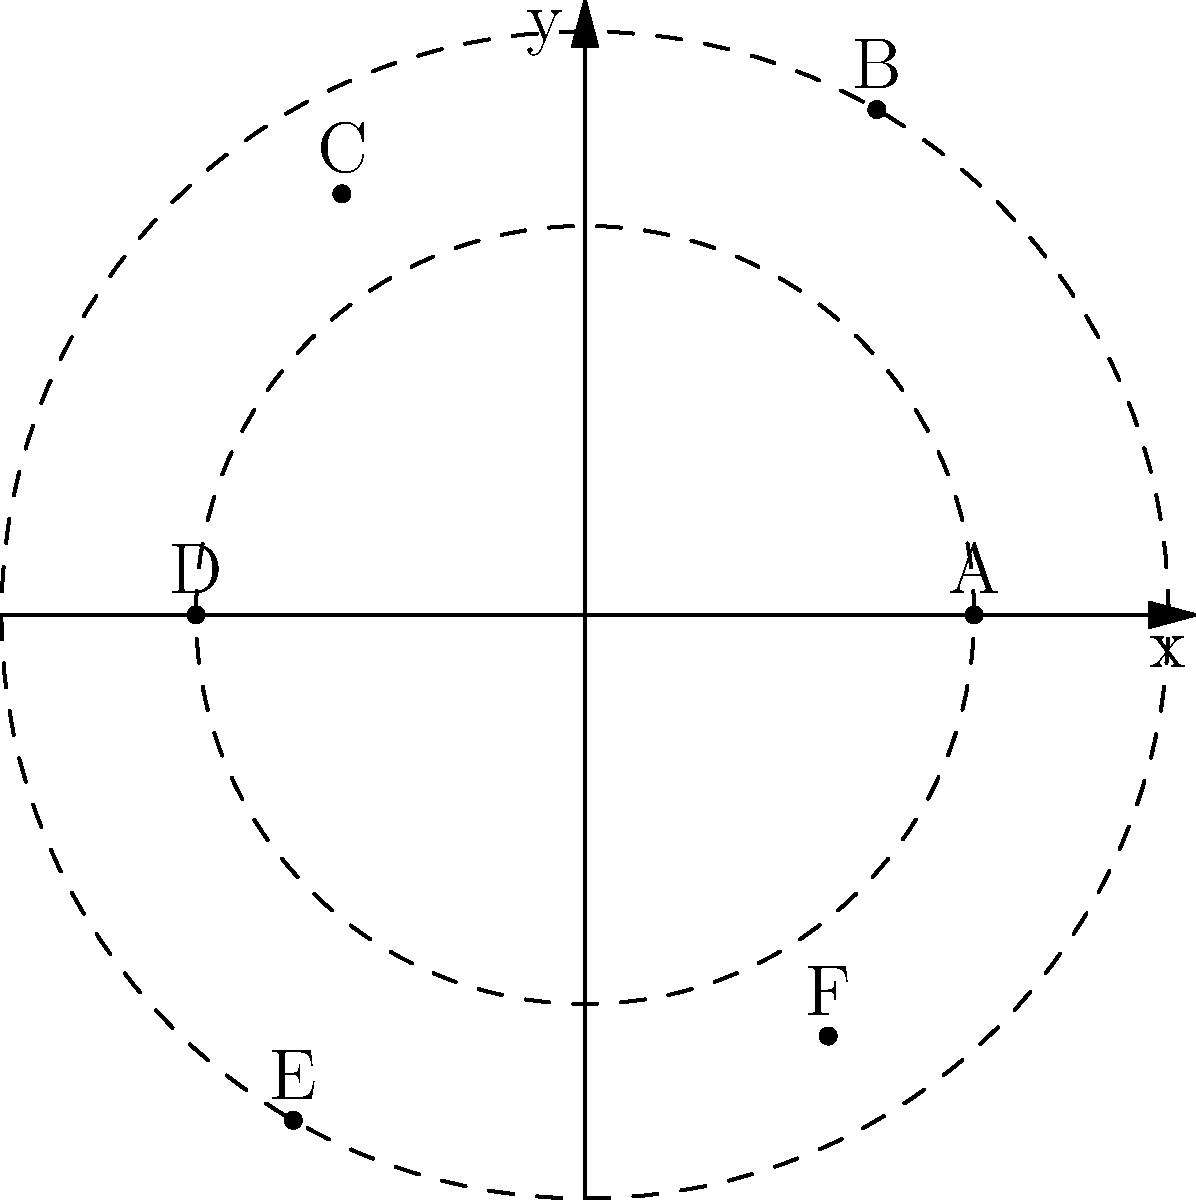In a circular village, six different plant specimens (A, B, C, D, E, F) are located at various points. Their positions are given in polar coordinates $(r, \theta)$ as follows:
A: $(2, 0)$, B: $(3, \frac{\pi}{3})$, C: $(2.5, \frac{2\pi}{3})$, D: $(2, \pi)$, E: $(3, \frac{4\pi}{3})$, F: $(2.5, \frac{5\pi}{3})$
What is the shortest path to collect all specimens, starting and ending at plant A? Give your answer as the sequence of plants visited. To find the shortest path, we need to consider the angular positions of the plants:

1. Start at A $(0)$
2. Move clockwise to F $(\frac{5\pi}{3})$
3. Continue to E $(\frac{4\pi}{3})$
4. Then to D $(\pi)$
5. Move to C $(\frac{2\pi}{3})$
6. Then to B $(\frac{\pi}{3})$
7. Finally, return to A $(0)$

This path minimizes the angular distance traveled, which corresponds to the shortest path along the circumference of the village. The radial distances are less significant for the total path length compared to the angular distances in this case.

The sequence A-F-E-D-C-B-A covers all plants in the shortest possible path, always moving to the nearest unvisited plant in terms of angular distance.
Answer: A-F-E-D-C-B-A 